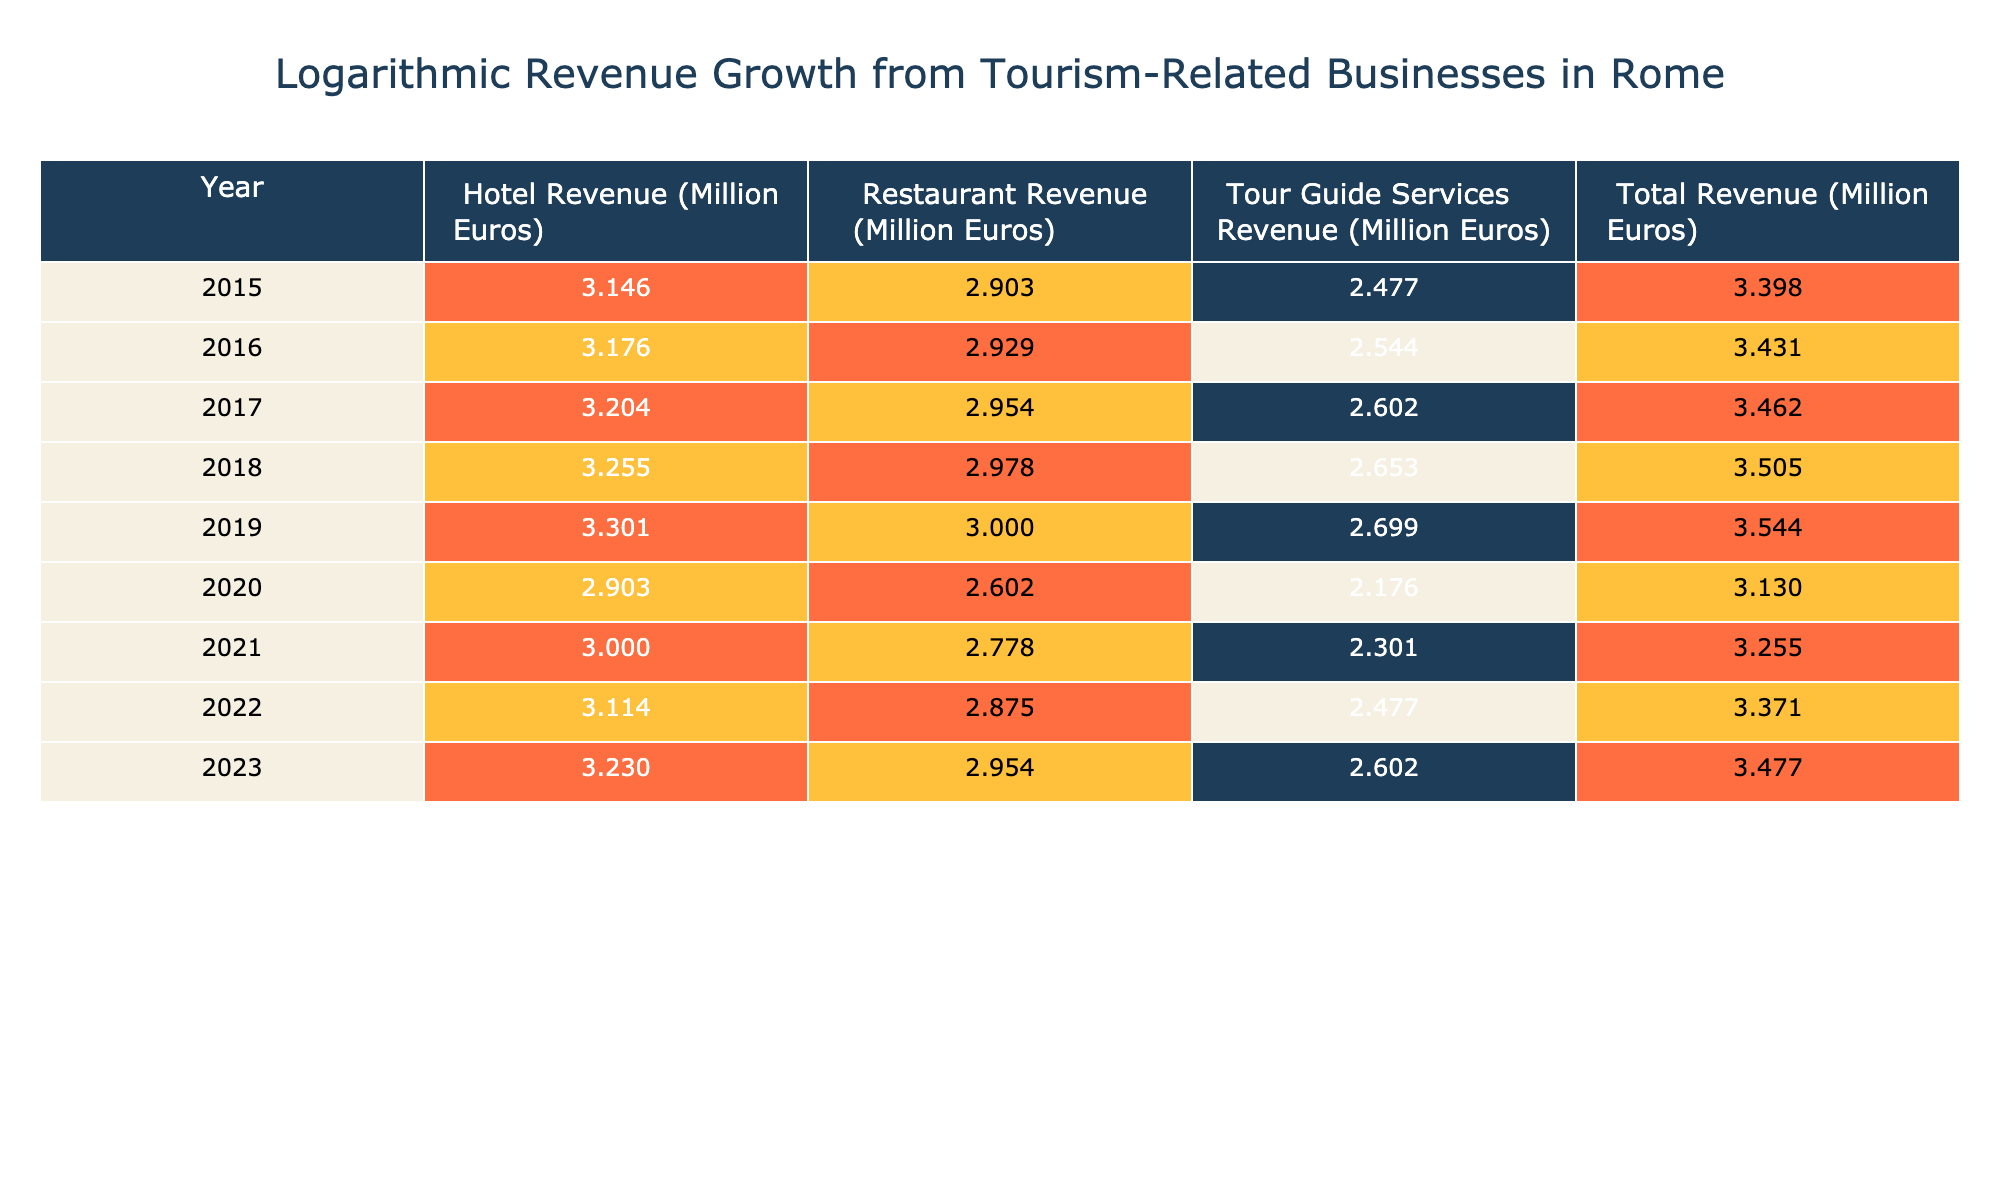What was the hotel revenue in 2020? The hotel revenue for the year 2020 is listed directly in the table under the "Hotel Revenue" column, which shows 800 million Euros.
Answer: 800 million Euros What is the total revenue for 2019? The total revenue for the year 2019 can be found in the "Total Revenue" column in the table, which indicates a value of 3500 million Euros.
Answer: 3500 million Euros What was the increase in restaurant revenue from 2015 to 2023? To calculate the increase in restaurant revenue, subtract the 2015 value (800 million Euros) from the 2023 value (900 million Euros). The difference is 900 - 800 = 100 million Euros.
Answer: 100 million Euros Is the total revenue higher in 2022 than in 2021? By checking the "Total Revenue" values for 2021 (1800 million Euros) and 2022 (2350 million Euros), it is clear that 2350 million is more than 1800 million, confirming that the statement is true.
Answer: Yes What was the average annual hotel revenue from 2015 to 2019? To find the average hotel revenue, first sum the revenues from 2015 to 2019: 1400 + 1500 + 1600 + 1800 + 2000 = 9300 million Euros. Then divide the sum by the number of years (5): 9300 / 5 = 1860 million Euros.
Answer: 1860 million Euros What was the total decrease in tour guide services revenue from 2019 to 2020? First, identify the revenues for 2019 (500 million Euros) and 2020 (150 million Euros). The decrease is calculated by subtracting the 2020 revenue from the 2019 revenue: 500 - 150 = 350 million Euros, indicating a significant drop in this category.
Answer: 350 million Euros Did restaurant revenue ever exceed hotel revenue from 2015 to 2019? Reviewing the revenues shows that hotel revenue was 1400, 1500, 1600, 1800, and 2000 million Euros for 2015 to 2019, while restaurant revenue was 800, 850, 900, 950, and 1000 million Euros respectively. Therefore, restaurant revenue never exceeded hotel revenue in this period, making the statement false.
Answer: No What is the difference in total revenue between the years 2019 and 2023? The total revenue for 2019 is 3500 million Euros, and the total revenue for 2023 is 3000 million Euros. The difference is calculated by subtracting the 2023 total from the 2019 total: 3500 - 3000 = 500 million Euros, indicating a decrease in overall revenue.
Answer: 500 million Euros 